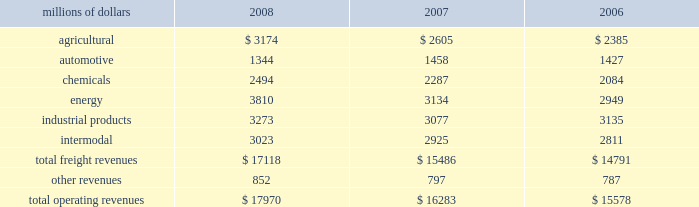Notes to the consolidated financial statements union pacific corporation and subsidiary companies for purposes of this report , unless the context otherwise requires , all references herein to the 201ccorporation 201d , 201cupc 201d , 201cwe 201d , 201cus 201d , and 201cour 201d mean union pacific corporation and its subsidiaries , including union pacific railroad company , which will be separately referred to herein as 201cuprr 201d or the 201crailroad 201d .
Nature of operations and significant accounting policies operations and segmentation 2013 we are a class i railroad that operates in the united states .
We have 32012 route miles , linking pacific coast and gulf coast ports with the midwest and eastern united states gateways and providing several corridors to key mexican gateways .
We serve the western two- thirds of the country and maintain coordinated schedules with other rail carriers for the handling of freight to and from the atlantic coast , the pacific coast , the southeast , the southwest , canada , and mexico .
Export and import traffic is moved through gulf coast and pacific coast ports and across the mexican and canadian borders .
The railroad , along with its subsidiaries and rail affiliates , is our one reportable operating segment .
Although revenues are analyzed by commodity group , we analyze the net financial results of the railroad as one segment due to the integrated nature of our rail network .
The table provides revenue by commodity group : millions of dollars 2008 2007 2006 .
Basis of presentation 2013 certain prior year amounts have been reclassified to conform to the current period financial statement presentation .
The reclassifications include reporting freight revenues instead of commodity revenues .
The amounts reclassified from freight revenues to other revenues totaled $ 30 million and $ 71 million for the years ended december 31 , 2007 , and december 31 , 2006 , respectively .
In addition , we modified our operating expense categories to report fuel used in railroad operations as a stand-alone category , to combine purchased services and materials into one line , and to reclassify certain other expenses among operating expense categories .
These reclassifications had no impact on previously reported operating revenues , total operating expenses , operating income or net income .
Significant accounting policies principles of consolidation 2013 the consolidated financial statements include the accounts of union pacific corporation and all of its subsidiaries .
Investments in affiliated companies ( 20% ( 20 % ) to 50% ( 50 % ) owned ) are accounted for using the equity method of accounting .
All significant intercompany transactions are eliminated .
The corporation evaluates its less than majority-owned investments for consolidation .
In 2008 what was the percent of the total freight revenues that was related to agricultural? 
Computations: (3174 / 17118)
Answer: 0.18542. 